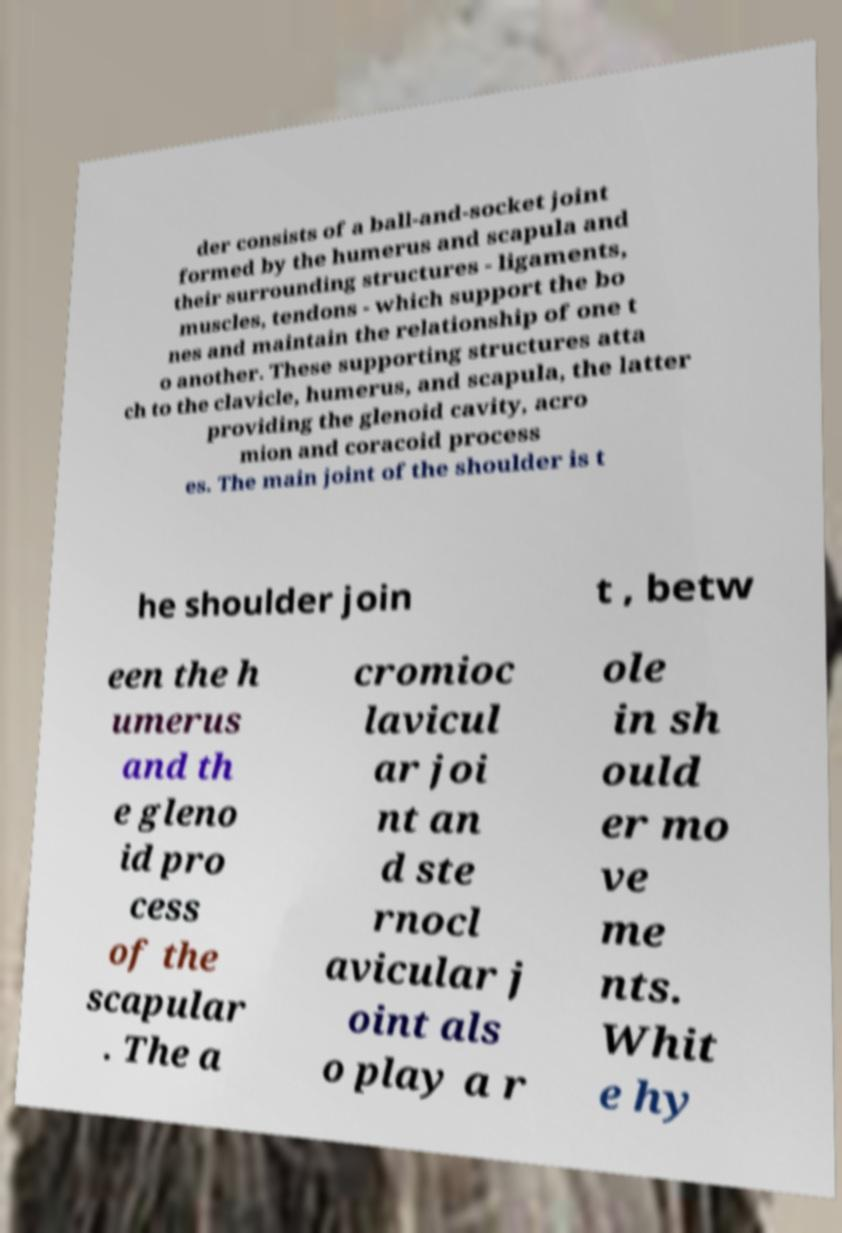What messages or text are displayed in this image? I need them in a readable, typed format. der consists of a ball-and-socket joint formed by the humerus and scapula and their surrounding structures - ligaments, muscles, tendons - which support the bo nes and maintain the relationship of one t o another. These supporting structures atta ch to the clavicle, humerus, and scapula, the latter providing the glenoid cavity, acro mion and coracoid process es. The main joint of the shoulder is t he shoulder join t , betw een the h umerus and th e gleno id pro cess of the scapular . The a cromioc lavicul ar joi nt an d ste rnocl avicular j oint als o play a r ole in sh ould er mo ve me nts. Whit e hy 